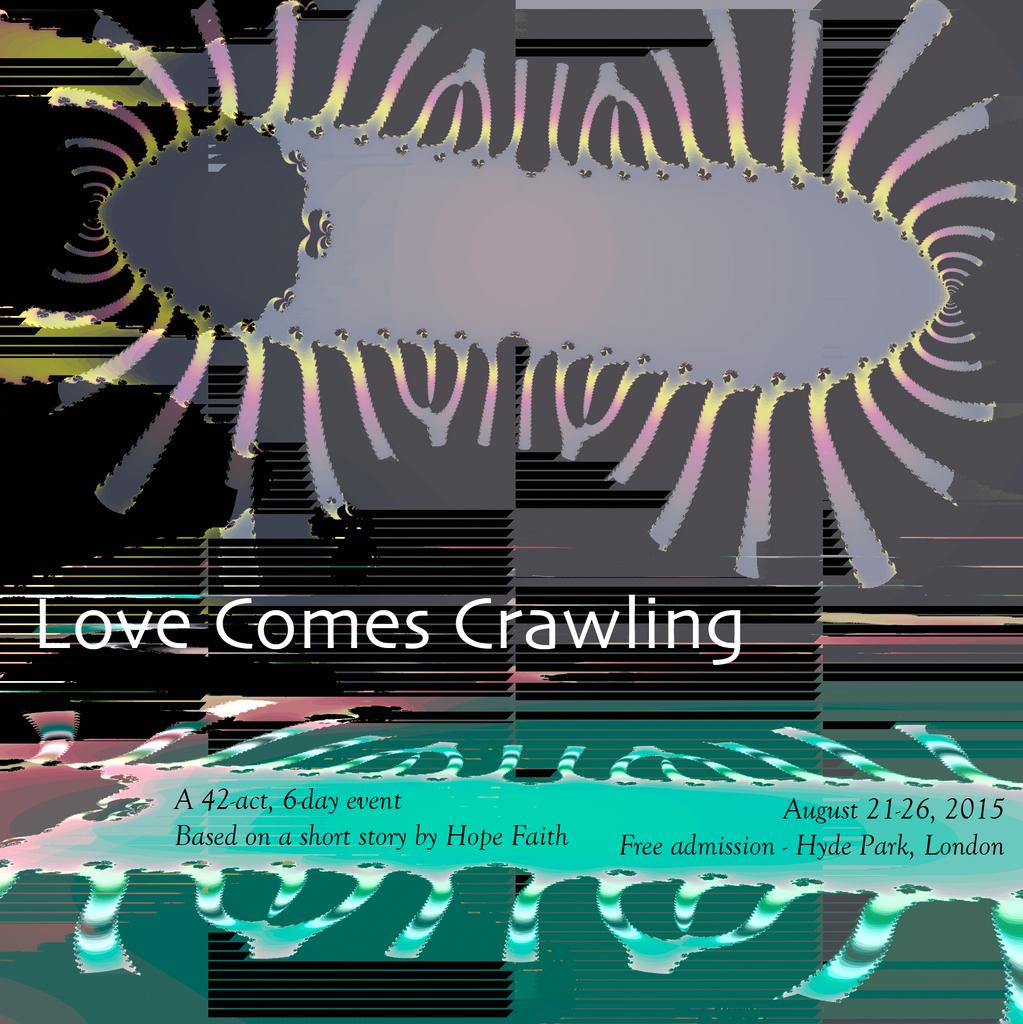What comes crawling?
Offer a terse response. Love. What comes crawling?
Keep it short and to the point. Love. 